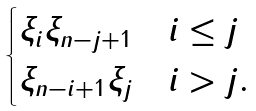Convert formula to latex. <formula><loc_0><loc_0><loc_500><loc_500>\begin{cases} \xi _ { i } \xi _ { n - j + 1 } & i \leq j \\ \xi _ { n - i + 1 } \xi _ { j } & i > j . \end{cases}</formula> 